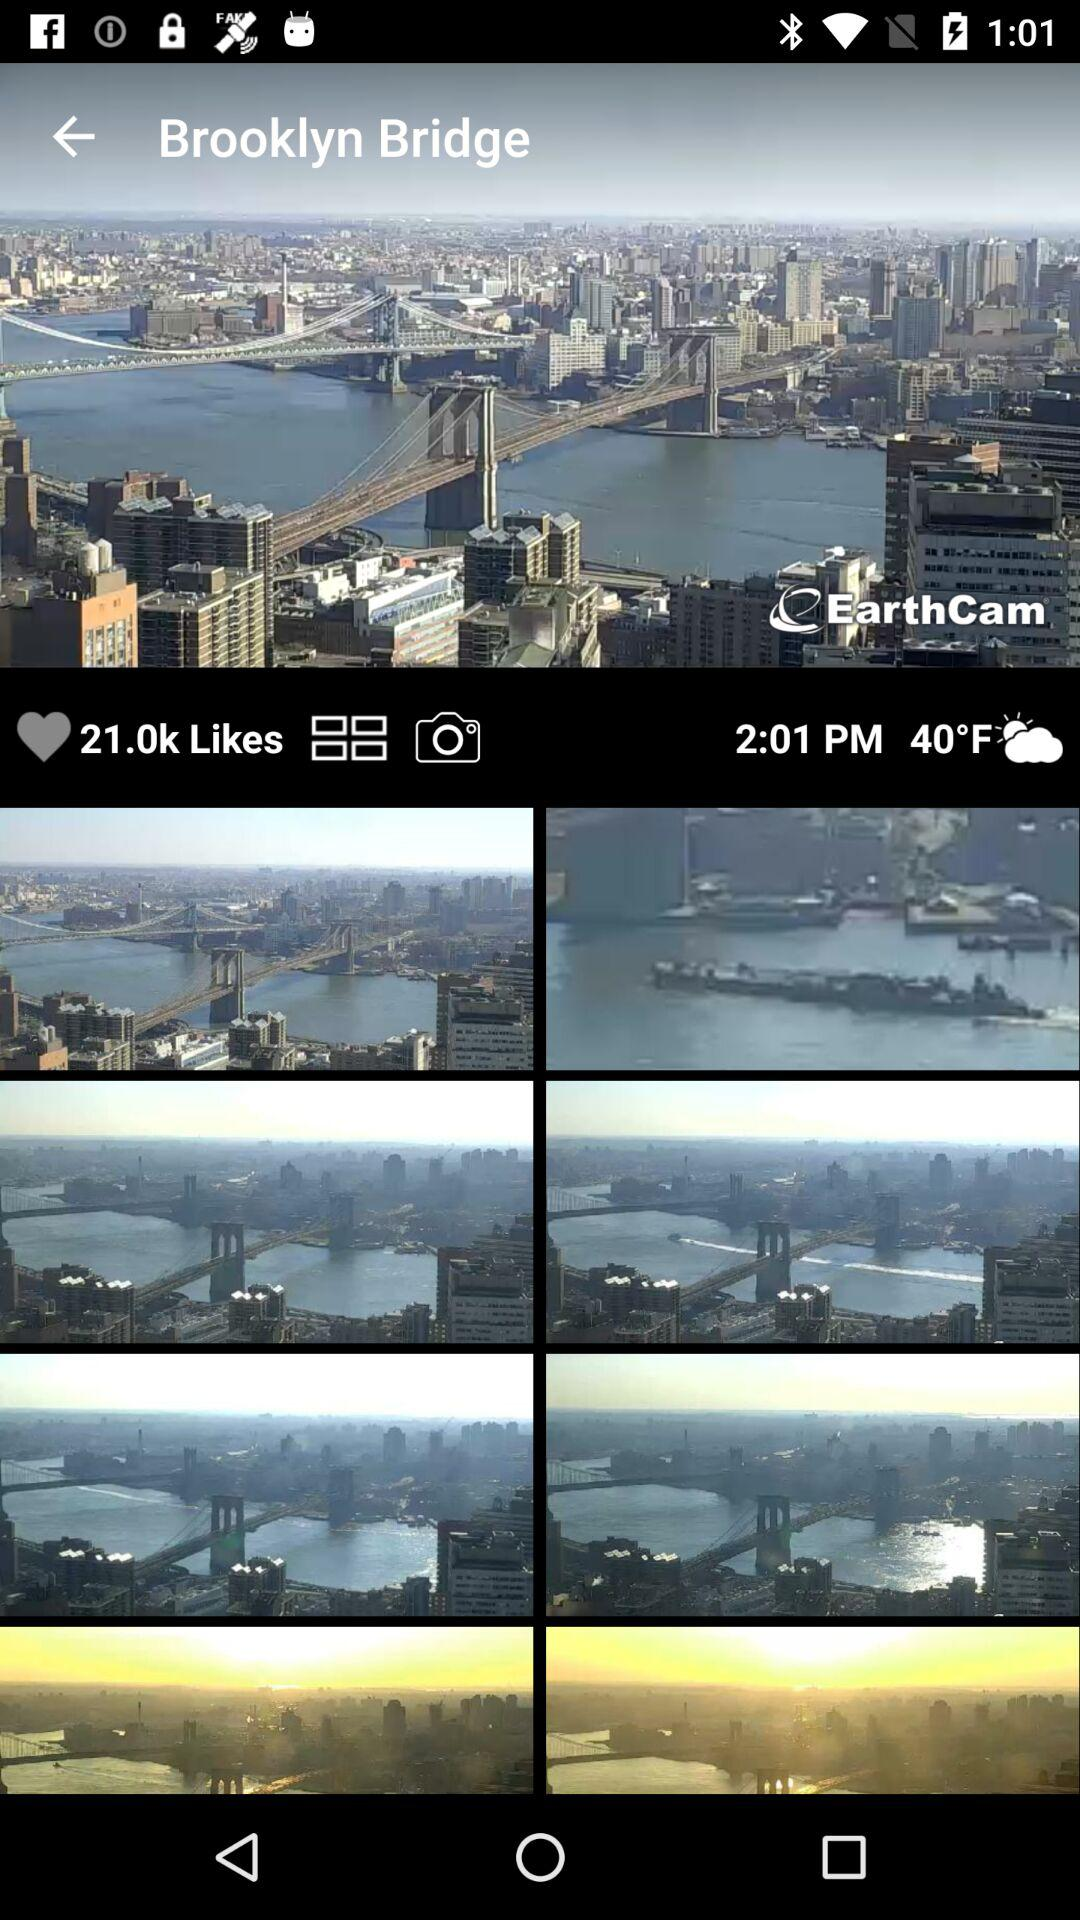What is the name of the mentioned watermark? The mentioned watermark is "EarthCam". 